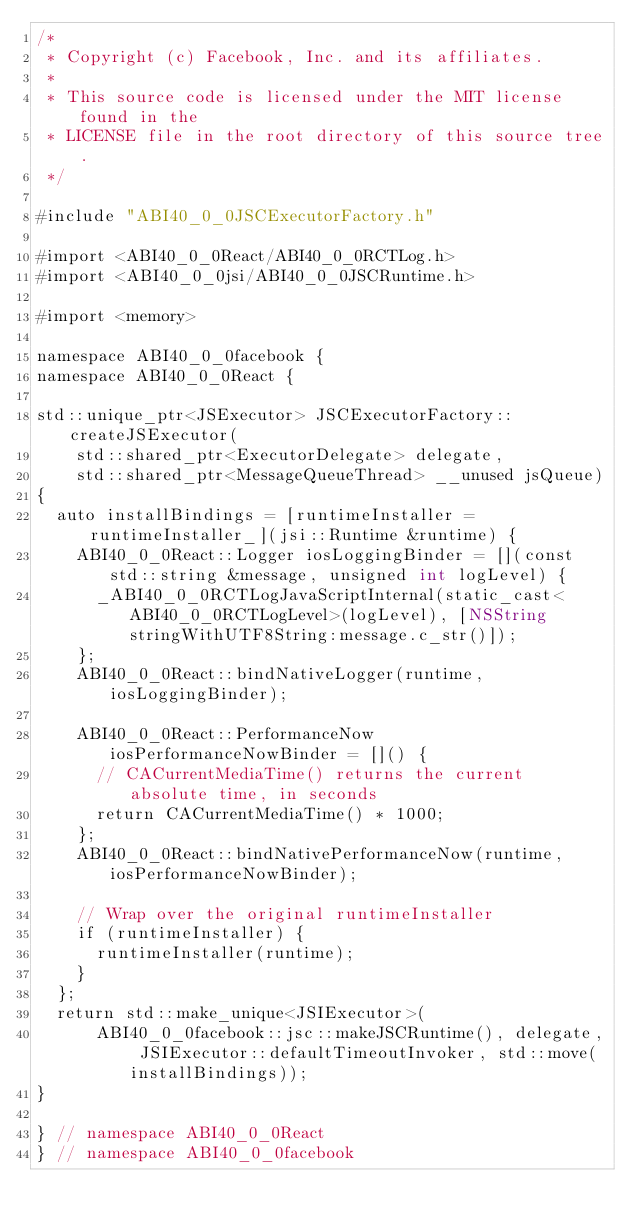<code> <loc_0><loc_0><loc_500><loc_500><_ObjectiveC_>/*
 * Copyright (c) Facebook, Inc. and its affiliates.
 *
 * This source code is licensed under the MIT license found in the
 * LICENSE file in the root directory of this source tree.
 */

#include "ABI40_0_0JSCExecutorFactory.h"

#import <ABI40_0_0React/ABI40_0_0RCTLog.h>
#import <ABI40_0_0jsi/ABI40_0_0JSCRuntime.h>

#import <memory>

namespace ABI40_0_0facebook {
namespace ABI40_0_0React {

std::unique_ptr<JSExecutor> JSCExecutorFactory::createJSExecutor(
    std::shared_ptr<ExecutorDelegate> delegate,
    std::shared_ptr<MessageQueueThread> __unused jsQueue)
{
  auto installBindings = [runtimeInstaller = runtimeInstaller_](jsi::Runtime &runtime) {
    ABI40_0_0React::Logger iosLoggingBinder = [](const std::string &message, unsigned int logLevel) {
      _ABI40_0_0RCTLogJavaScriptInternal(static_cast<ABI40_0_0RCTLogLevel>(logLevel), [NSString stringWithUTF8String:message.c_str()]);
    };
    ABI40_0_0React::bindNativeLogger(runtime, iosLoggingBinder);

    ABI40_0_0React::PerformanceNow iosPerformanceNowBinder = []() {
      // CACurrentMediaTime() returns the current absolute time, in seconds
      return CACurrentMediaTime() * 1000;
    };
    ABI40_0_0React::bindNativePerformanceNow(runtime, iosPerformanceNowBinder);

    // Wrap over the original runtimeInstaller
    if (runtimeInstaller) {
      runtimeInstaller(runtime);
    }
  };
  return std::make_unique<JSIExecutor>(
      ABI40_0_0facebook::jsc::makeJSCRuntime(), delegate, JSIExecutor::defaultTimeoutInvoker, std::move(installBindings));
}

} // namespace ABI40_0_0React
} // namespace ABI40_0_0facebook
</code> 